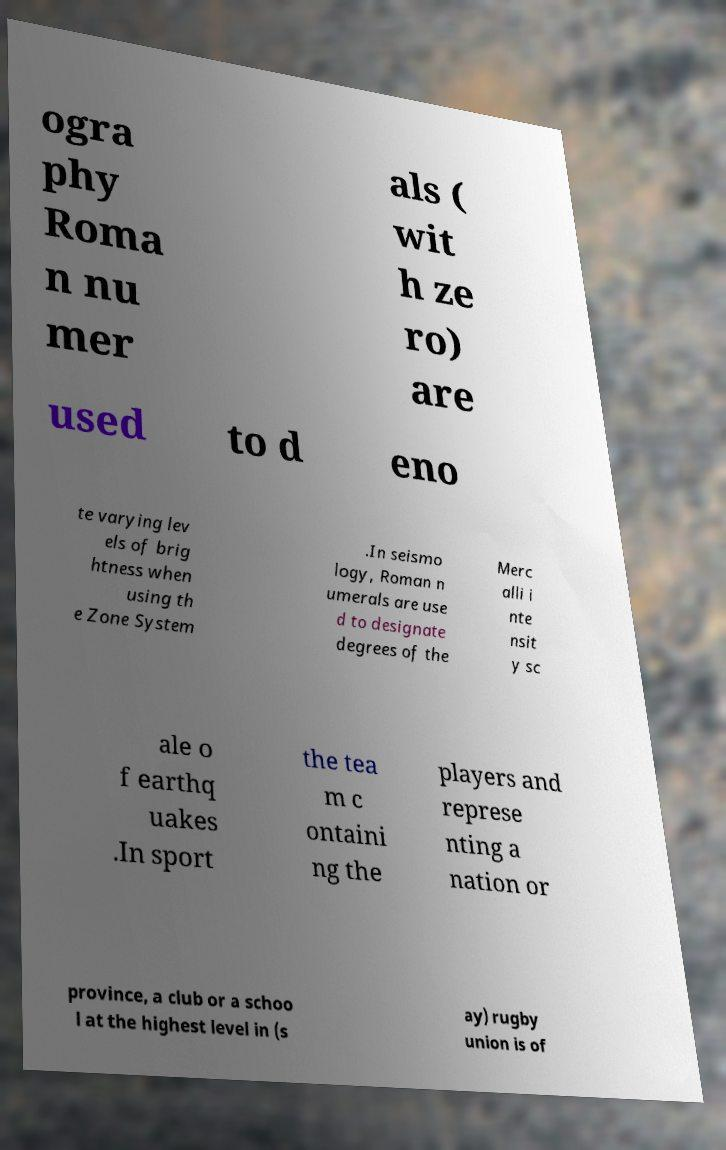For documentation purposes, I need the text within this image transcribed. Could you provide that? ogra phy Roma n nu mer als ( wit h ze ro) are used to d eno te varying lev els of brig htness when using th e Zone System .In seismo logy, Roman n umerals are use d to designate degrees of the Merc alli i nte nsit y sc ale o f earthq uakes .In sport the tea m c ontaini ng the players and represe nting a nation or province, a club or a schoo l at the highest level in (s ay) rugby union is of 